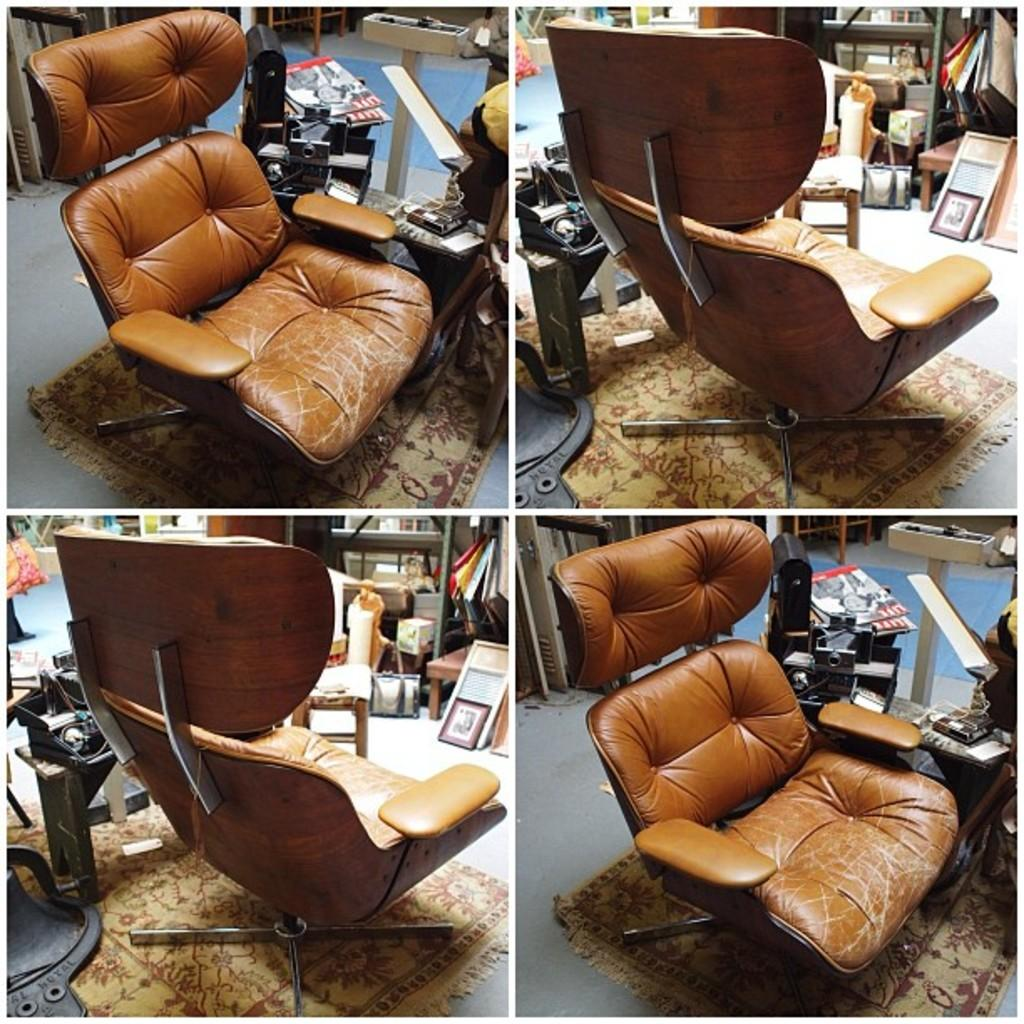What type of artwork is the image? The image is a collage of a room. What furniture can be seen in the room? There is a chair in the room. What type of storage container is in the room? There is a box in the room. What type of decorative items are in the room? There are frames in the room. What type of organizational feature is in the room? There are racks in the room. What type of floor covering is in the room? There is a door mat in the room. How many legs does the self in the room have? There is no self present in the room; it is a collage of a room with various objects and features. 